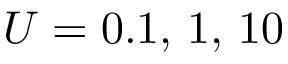Convert formula to latex. <formula><loc_0><loc_0><loc_500><loc_500>U = 0 . 1 , \, 1 , \, 1 0</formula> 